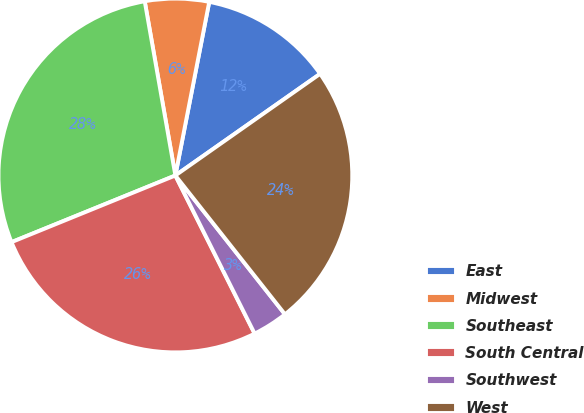<chart> <loc_0><loc_0><loc_500><loc_500><pie_chart><fcel>East<fcel>Midwest<fcel>Southeast<fcel>South Central<fcel>Southwest<fcel>West<nl><fcel>12.19%<fcel>5.84%<fcel>28.38%<fcel>26.25%<fcel>3.24%<fcel>24.11%<nl></chart> 